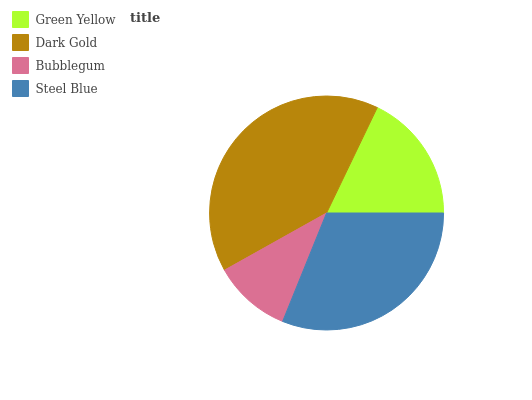Is Bubblegum the minimum?
Answer yes or no. Yes. Is Dark Gold the maximum?
Answer yes or no. Yes. Is Dark Gold the minimum?
Answer yes or no. No. Is Bubblegum the maximum?
Answer yes or no. No. Is Dark Gold greater than Bubblegum?
Answer yes or no. Yes. Is Bubblegum less than Dark Gold?
Answer yes or no. Yes. Is Bubblegum greater than Dark Gold?
Answer yes or no. No. Is Dark Gold less than Bubblegum?
Answer yes or no. No. Is Steel Blue the high median?
Answer yes or no. Yes. Is Green Yellow the low median?
Answer yes or no. Yes. Is Bubblegum the high median?
Answer yes or no. No. Is Dark Gold the low median?
Answer yes or no. No. 